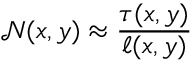<formula> <loc_0><loc_0><loc_500><loc_500>\mathcal { N } ( x , y ) \approx \frac { \tau ( x , y ) } { \ell ( x , y ) }</formula> 